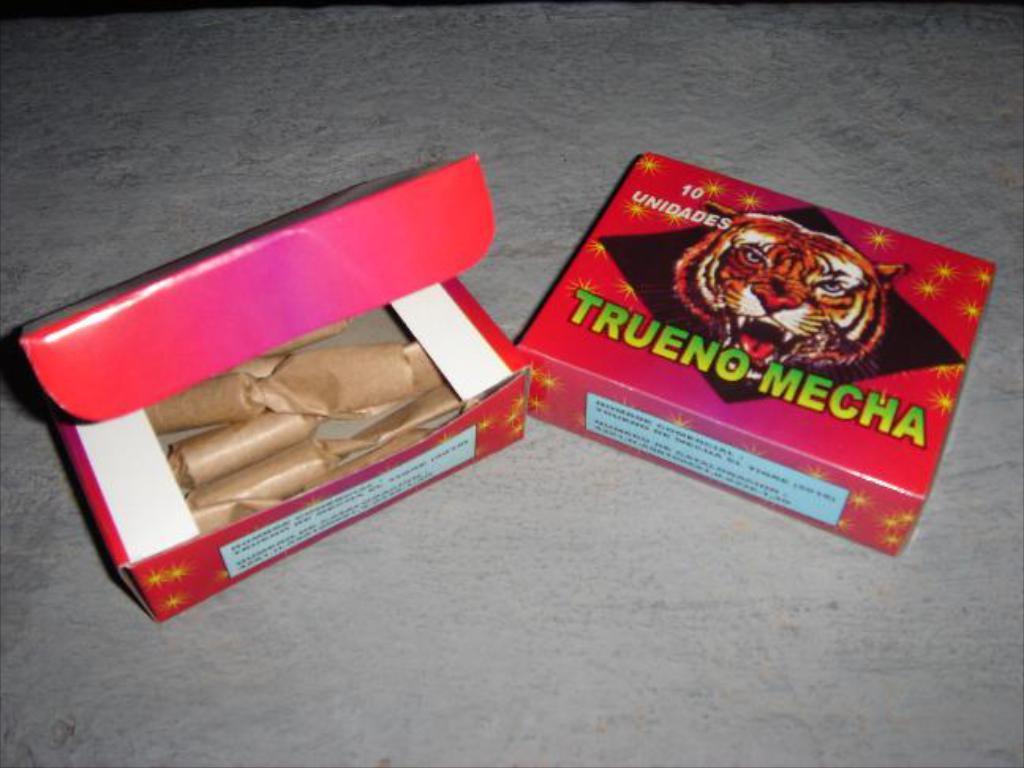Can you describe this image briefly? In this image we can see the cardboard cartons placed on the floor. 